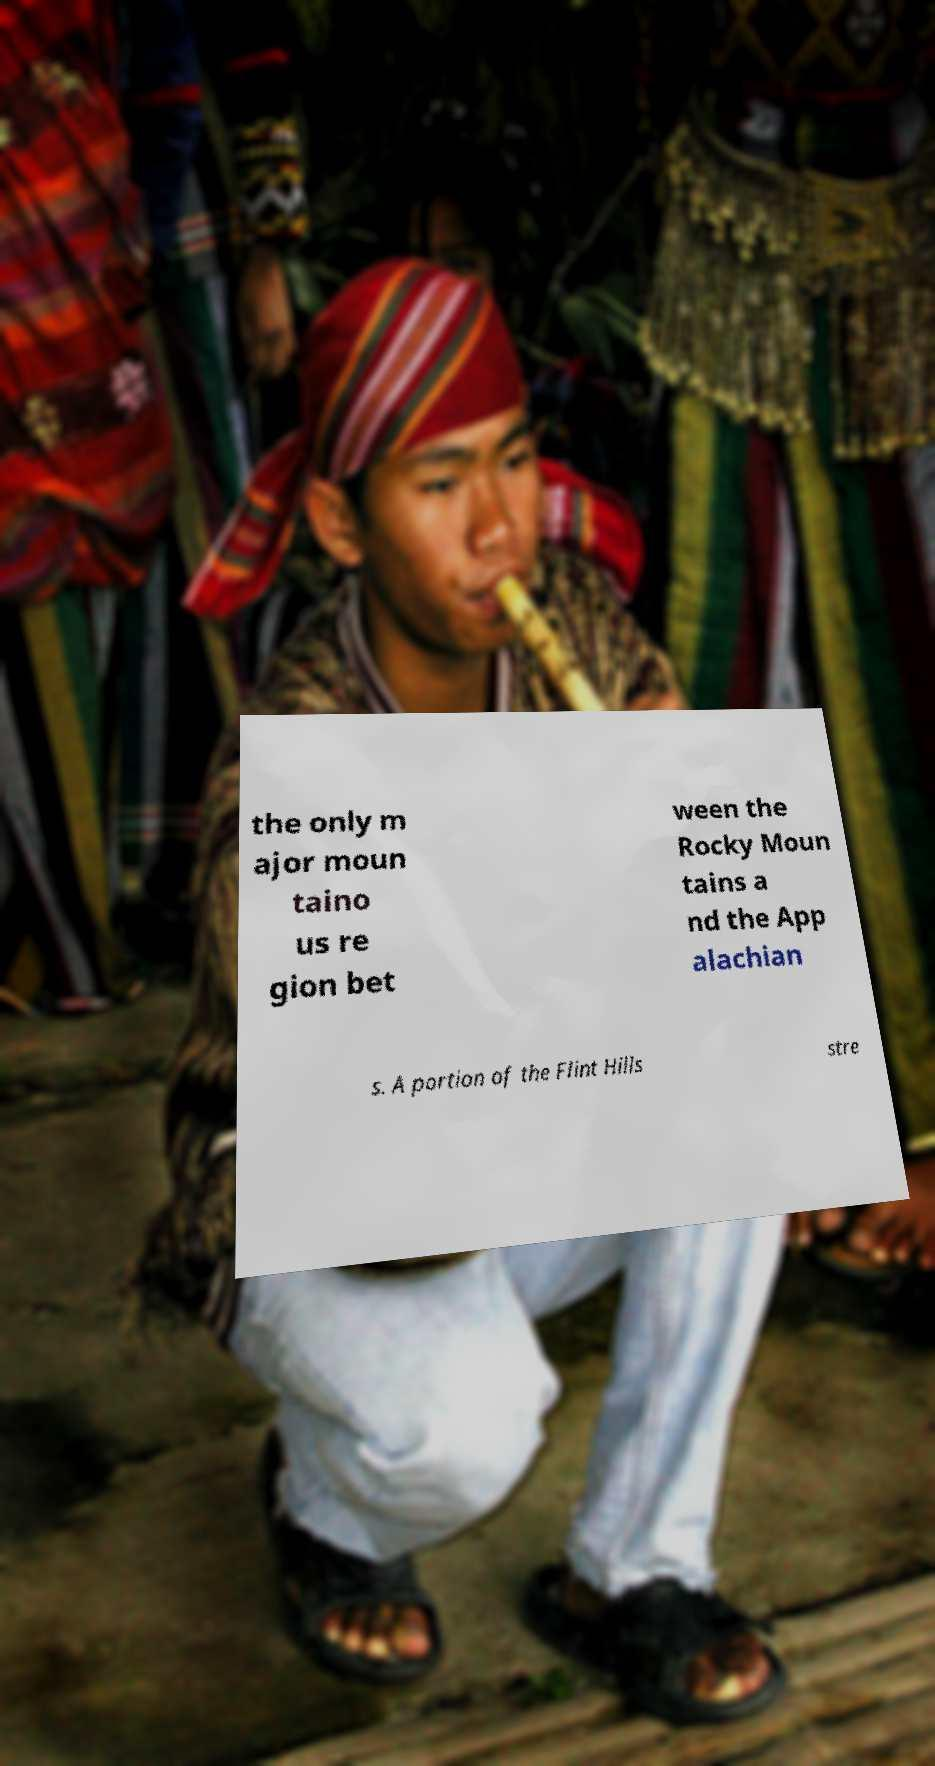Could you extract and type out the text from this image? the only m ajor moun taino us re gion bet ween the Rocky Moun tains a nd the App alachian s. A portion of the Flint Hills stre 